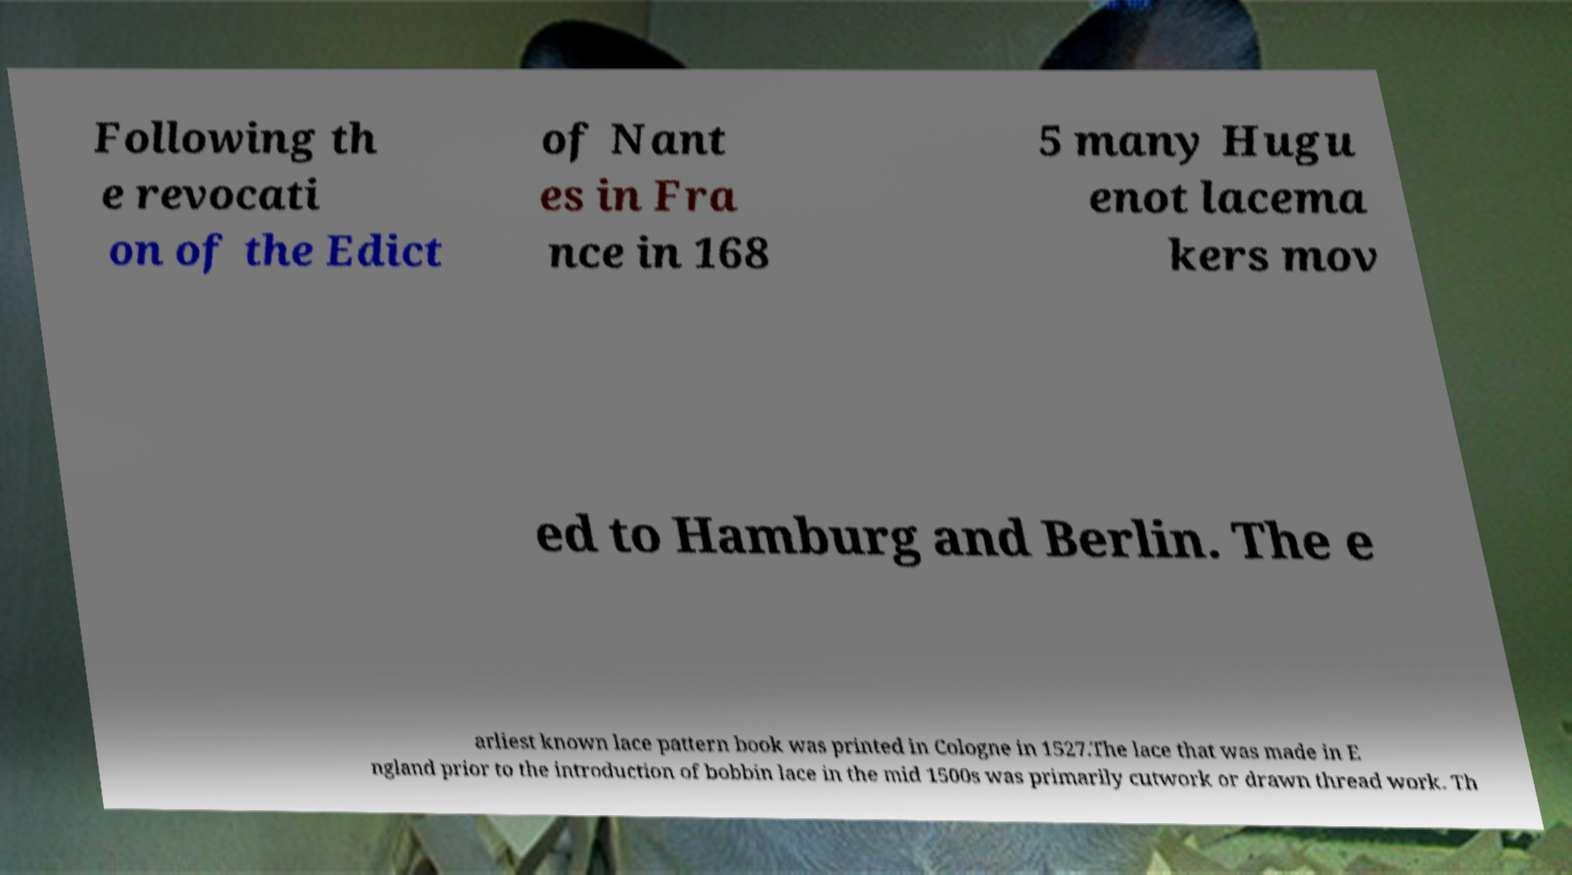What messages or text are displayed in this image? I need them in a readable, typed format. Following th e revocati on of the Edict of Nant es in Fra nce in 168 5 many Hugu enot lacema kers mov ed to Hamburg and Berlin. The e arliest known lace pattern book was printed in Cologne in 1527.The lace that was made in E ngland prior to the introduction of bobbin lace in the mid 1500s was primarily cutwork or drawn thread work. Th 